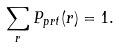<formula> <loc_0><loc_0><loc_500><loc_500>\sum _ { r } P _ { p r t } ( r ) = 1 .</formula> 